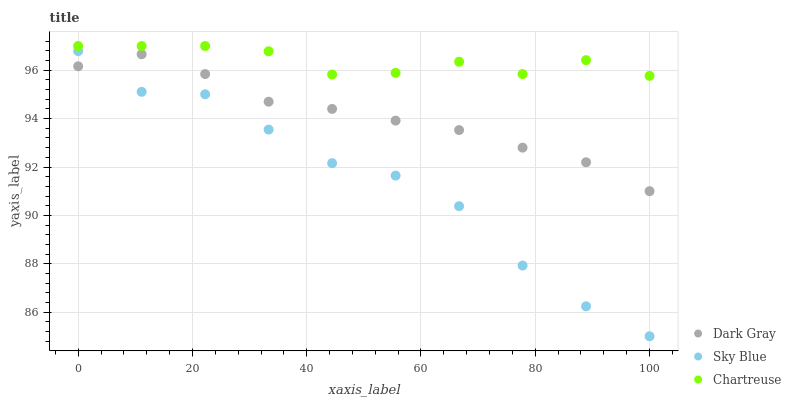Does Sky Blue have the minimum area under the curve?
Answer yes or no. Yes. Does Chartreuse have the maximum area under the curve?
Answer yes or no. Yes. Does Chartreuse have the minimum area under the curve?
Answer yes or no. No. Does Sky Blue have the maximum area under the curve?
Answer yes or no. No. Is Dark Gray the smoothest?
Answer yes or no. Yes. Is Sky Blue the roughest?
Answer yes or no. Yes. Is Chartreuse the smoothest?
Answer yes or no. No. Is Chartreuse the roughest?
Answer yes or no. No. Does Sky Blue have the lowest value?
Answer yes or no. Yes. Does Chartreuse have the lowest value?
Answer yes or no. No. Does Chartreuse have the highest value?
Answer yes or no. Yes. Does Sky Blue have the highest value?
Answer yes or no. No. Is Sky Blue less than Chartreuse?
Answer yes or no. Yes. Is Chartreuse greater than Sky Blue?
Answer yes or no. Yes. Does Dark Gray intersect Sky Blue?
Answer yes or no. Yes. Is Dark Gray less than Sky Blue?
Answer yes or no. No. Is Dark Gray greater than Sky Blue?
Answer yes or no. No. Does Sky Blue intersect Chartreuse?
Answer yes or no. No. 